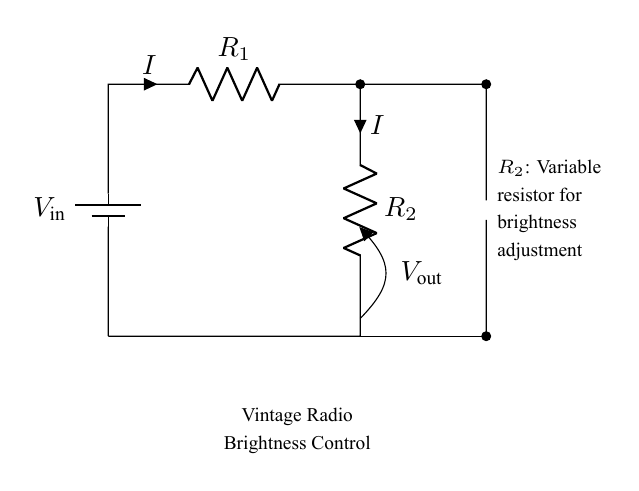What is the input voltage labeled in the circuit? The input voltage ($V_{\text{in}}$) is indicated at the top of the battery in the circuit diagram.
Answer: $V_{\text{in}}$ What do the two resistors in the circuit represent? The two resistors ($R_1$ and $R_2$) are part of the voltage divider which adjusts the output voltage.
Answer: Resistors What is the function of the variable resistor in this circuit? The variable resistor ($R_2$) is used to modify the brightness of the dial light by changing the current flowing through it.
Answer: Brightness adjustment What is the output voltage taken from in the circuit? The output voltage ($V_{\text{out}}$) is measured across the variable resistor and indicates the voltage applied to the dial light.
Answer: Across $R_2$ How does increasing the resistance of $R_2$ affect the brightness of the dial light? Increasing $R_2$ allows less current to flow through the dial light, resulting in decreased brightness.
Answer: Decreases brightness What current flows through the circuit, as indicated in the diagram? The circuit shows a current $I$ flowing through both resistors, which indicates the same current in a series circuit.
Answer: $I$ 